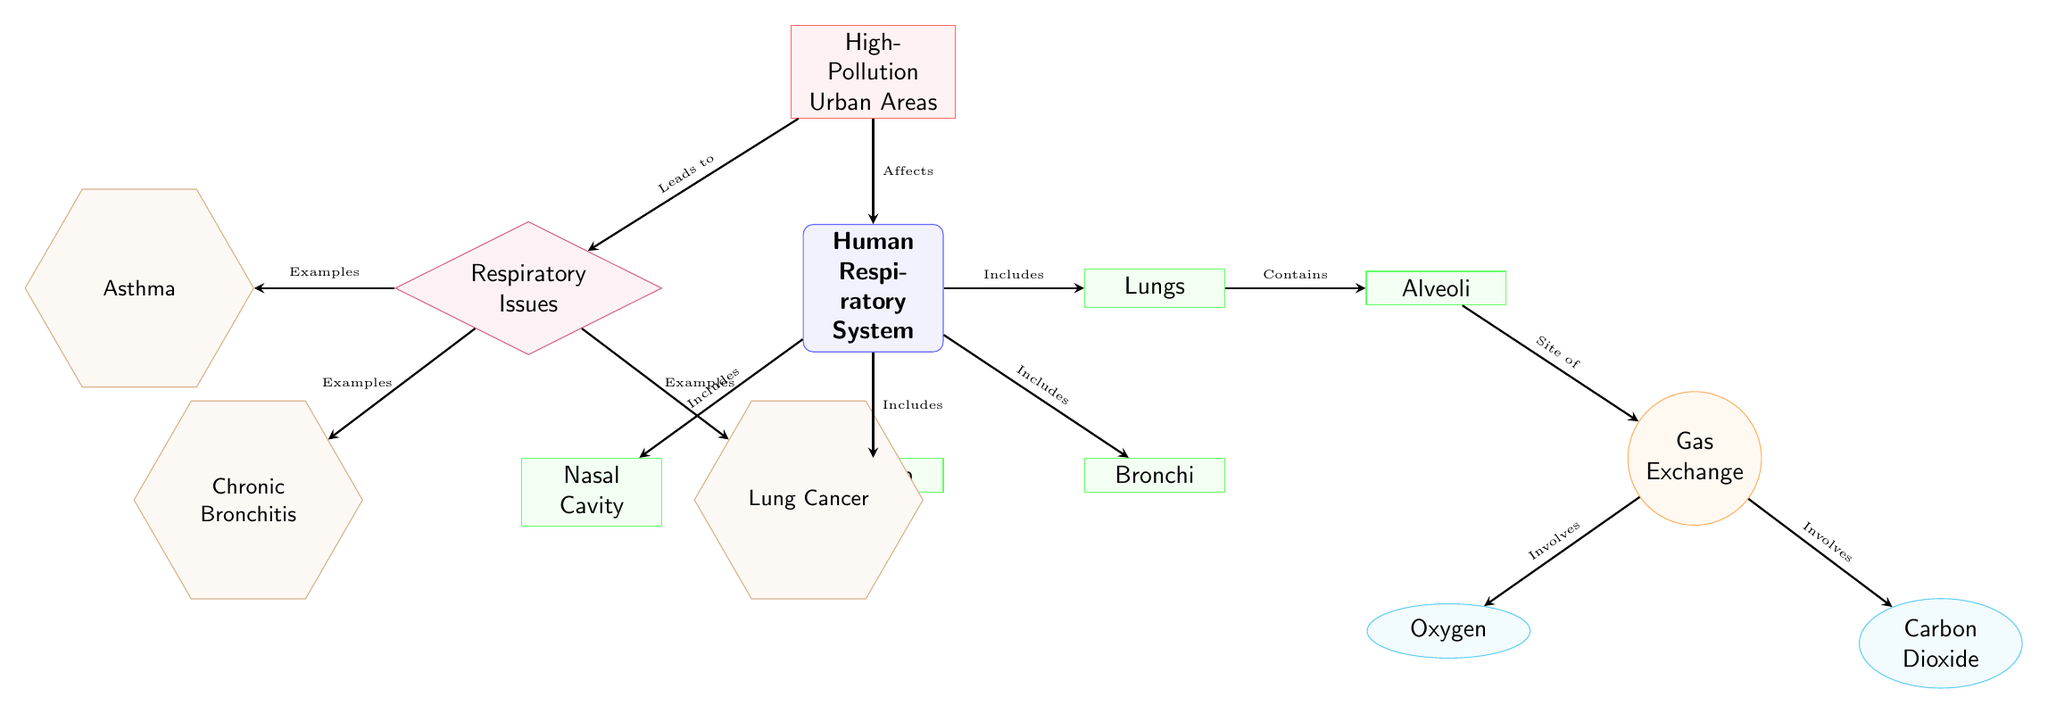What is the main subject of the diagram? The main subject, located at the top of the diagram, is labeled as "Human Respiratory System". This can be identified as the central node from which other nodes are connected, indicating that the diagram focuses on this specific system.
Answer: Human Respiratory System What anatomical structure connects the nasal cavity and the lungs? The anatomical structure that connects the nasal cavity to the lungs is the "Trachea," which is clearly depicted in the diagram as a downward path from the nasal cavity to the lungs, forming a crucial part of the respiratory system.
Answer: Trachea How many common respiratory issues are listed in the diagram? The diagram lists three common respiratory issues: Asthma, Chronic Bronchitis, and Lung Cancer. By counting the condition nodes connected to the "Respiratory Issues" node, we confirm there are three distinct issues presented.
Answer: 3 What gas is shown to be involved in the gas exchange process? The gas involved in the gas exchange process that is highlighted in the diagram is "Oxygen." This is shown as a node that emerges from the "Gas Exchange" process, indicating its importance in respiration.
Answer: Oxygen Which environmental context is said to affect the human respiratory system? The environmental context that affects the human respiratory system is indicated as "High-Pollution Urban Areas," which is positioned above the main subject node and is labeled as having an influence on respiratory health.
Answer: High-Pollution Urban Areas What relationship does the diagram indicate between high pollution and respiratory issues? The diagram indicates that "High-Pollution Urban Areas" lead to "Respiratory Issues." This connection is drawn through an arrow showing the impact of pollution on health, emphasizing the negative consequences of a polluted environment.
Answer: Leads to What two gases are produced during the gas exchange process? The two gases that are produced during the gas exchange process are "Oxygen" and "Carbon Dioxide." These gases are represented separately as outcomes of the gas exchange process, which is a critical function in the lungs.
Answer: Oxygen and Carbon Dioxide What process occurs in the alveoli? The process that occurs in the alveoli is "Gas Exchange." This is positioned directly beneath the alveoli in the diagram, illustrating that this is the site where oxygen and carbon dioxide are exchanged.
Answer: Gas Exchange What is one example of a respiratory issue caused by pollution? One example of a respiratory issue caused by pollution, as indicated in the diagram, is "Asthma." It is listed under the "Respiratory Issues" node, highlighting it as a consequence of high pollution levels.
Answer: Asthma 